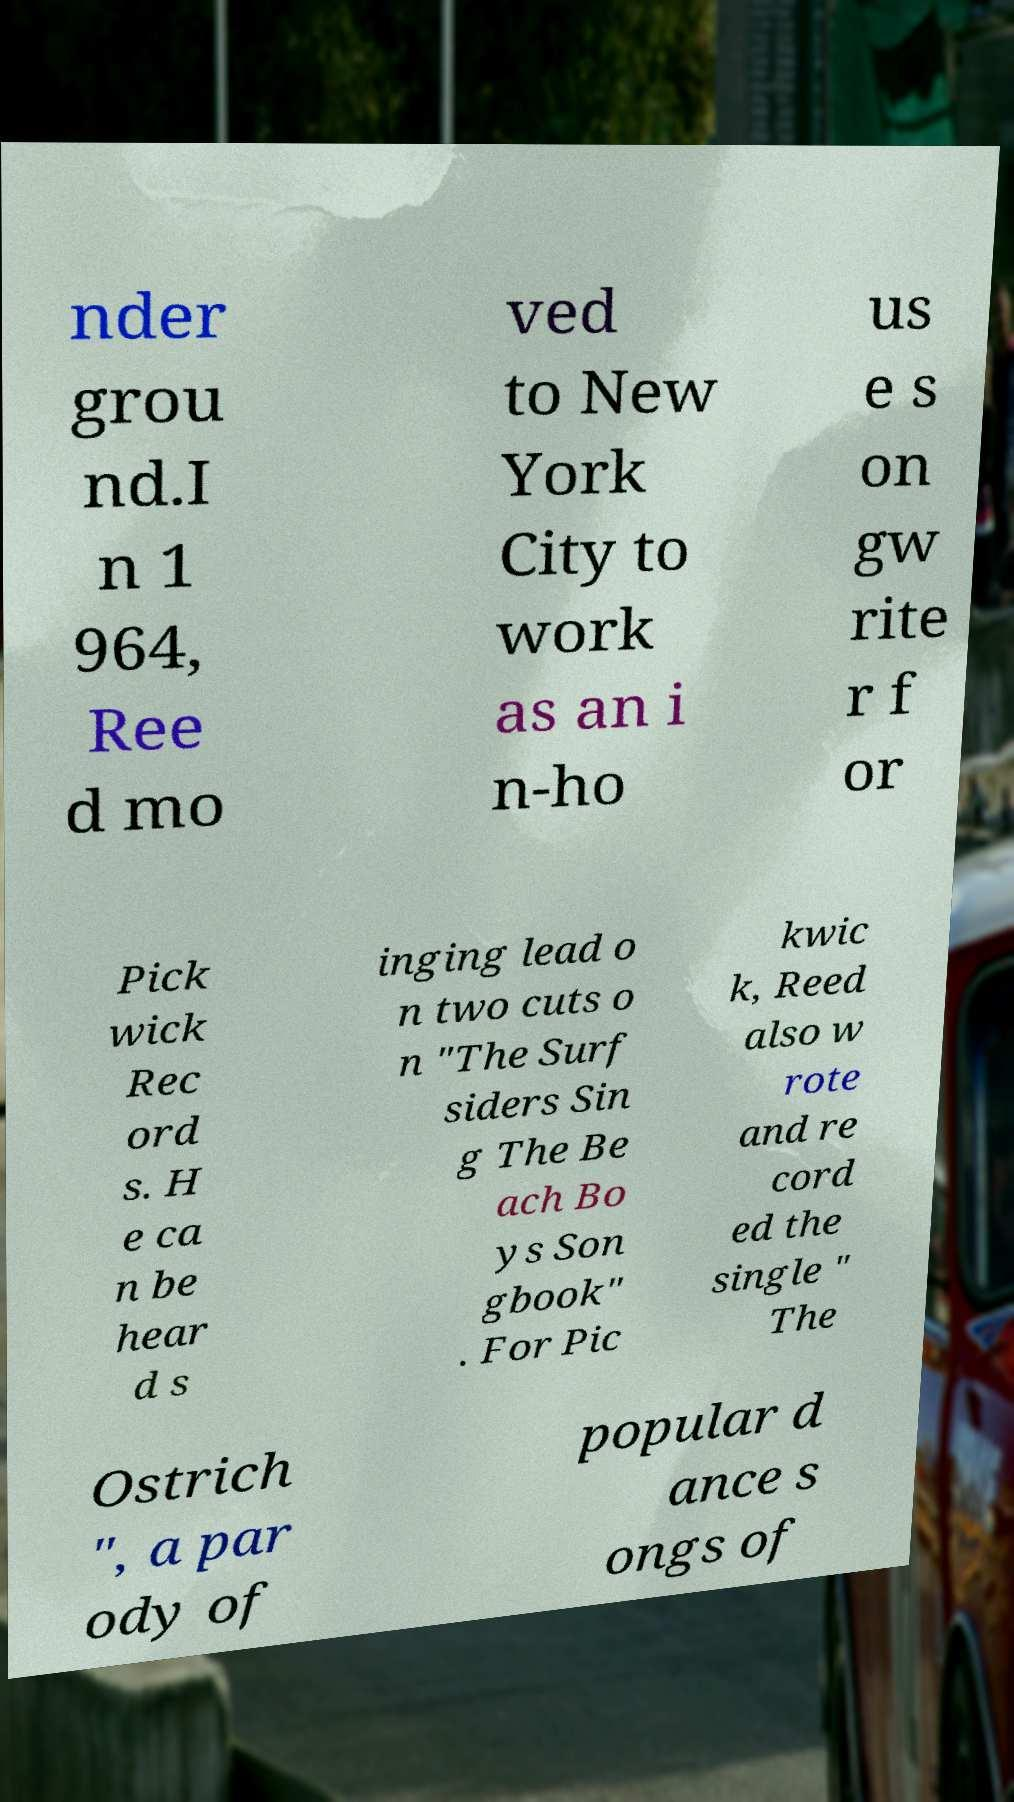Can you accurately transcribe the text from the provided image for me? nder grou nd.I n 1 964, Ree d mo ved to New York City to work as an i n-ho us e s on gw rite r f or Pick wick Rec ord s. H e ca n be hear d s inging lead o n two cuts o n "The Surf siders Sin g The Be ach Bo ys Son gbook" . For Pic kwic k, Reed also w rote and re cord ed the single " The Ostrich ", a par ody of popular d ance s ongs of 